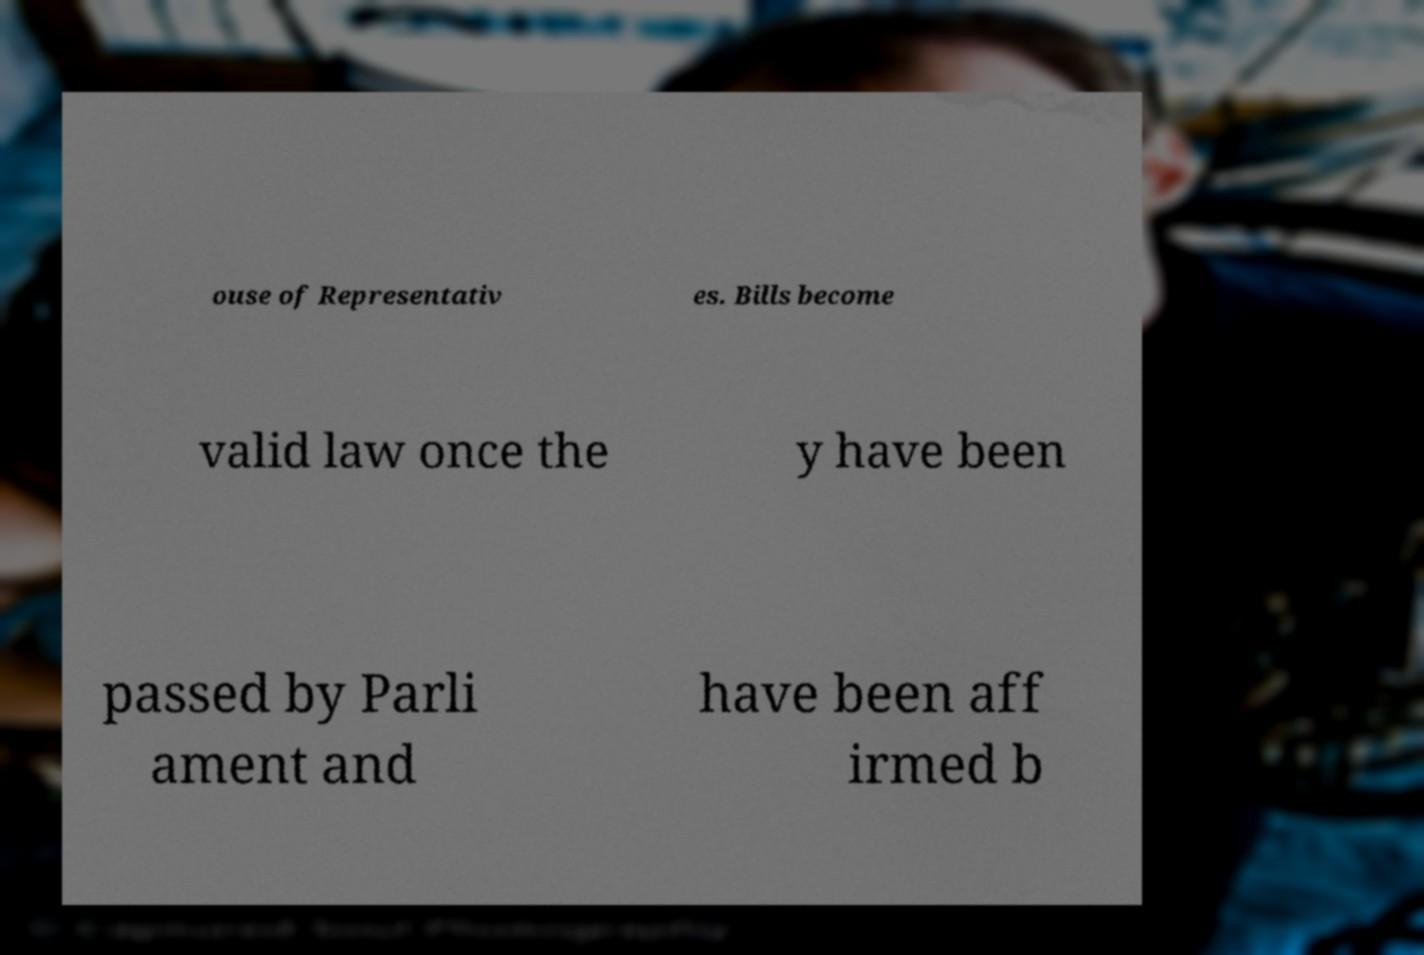Can you read and provide the text displayed in the image?This photo seems to have some interesting text. Can you extract and type it out for me? ouse of Representativ es. Bills become valid law once the y have been passed by Parli ament and have been aff irmed b 